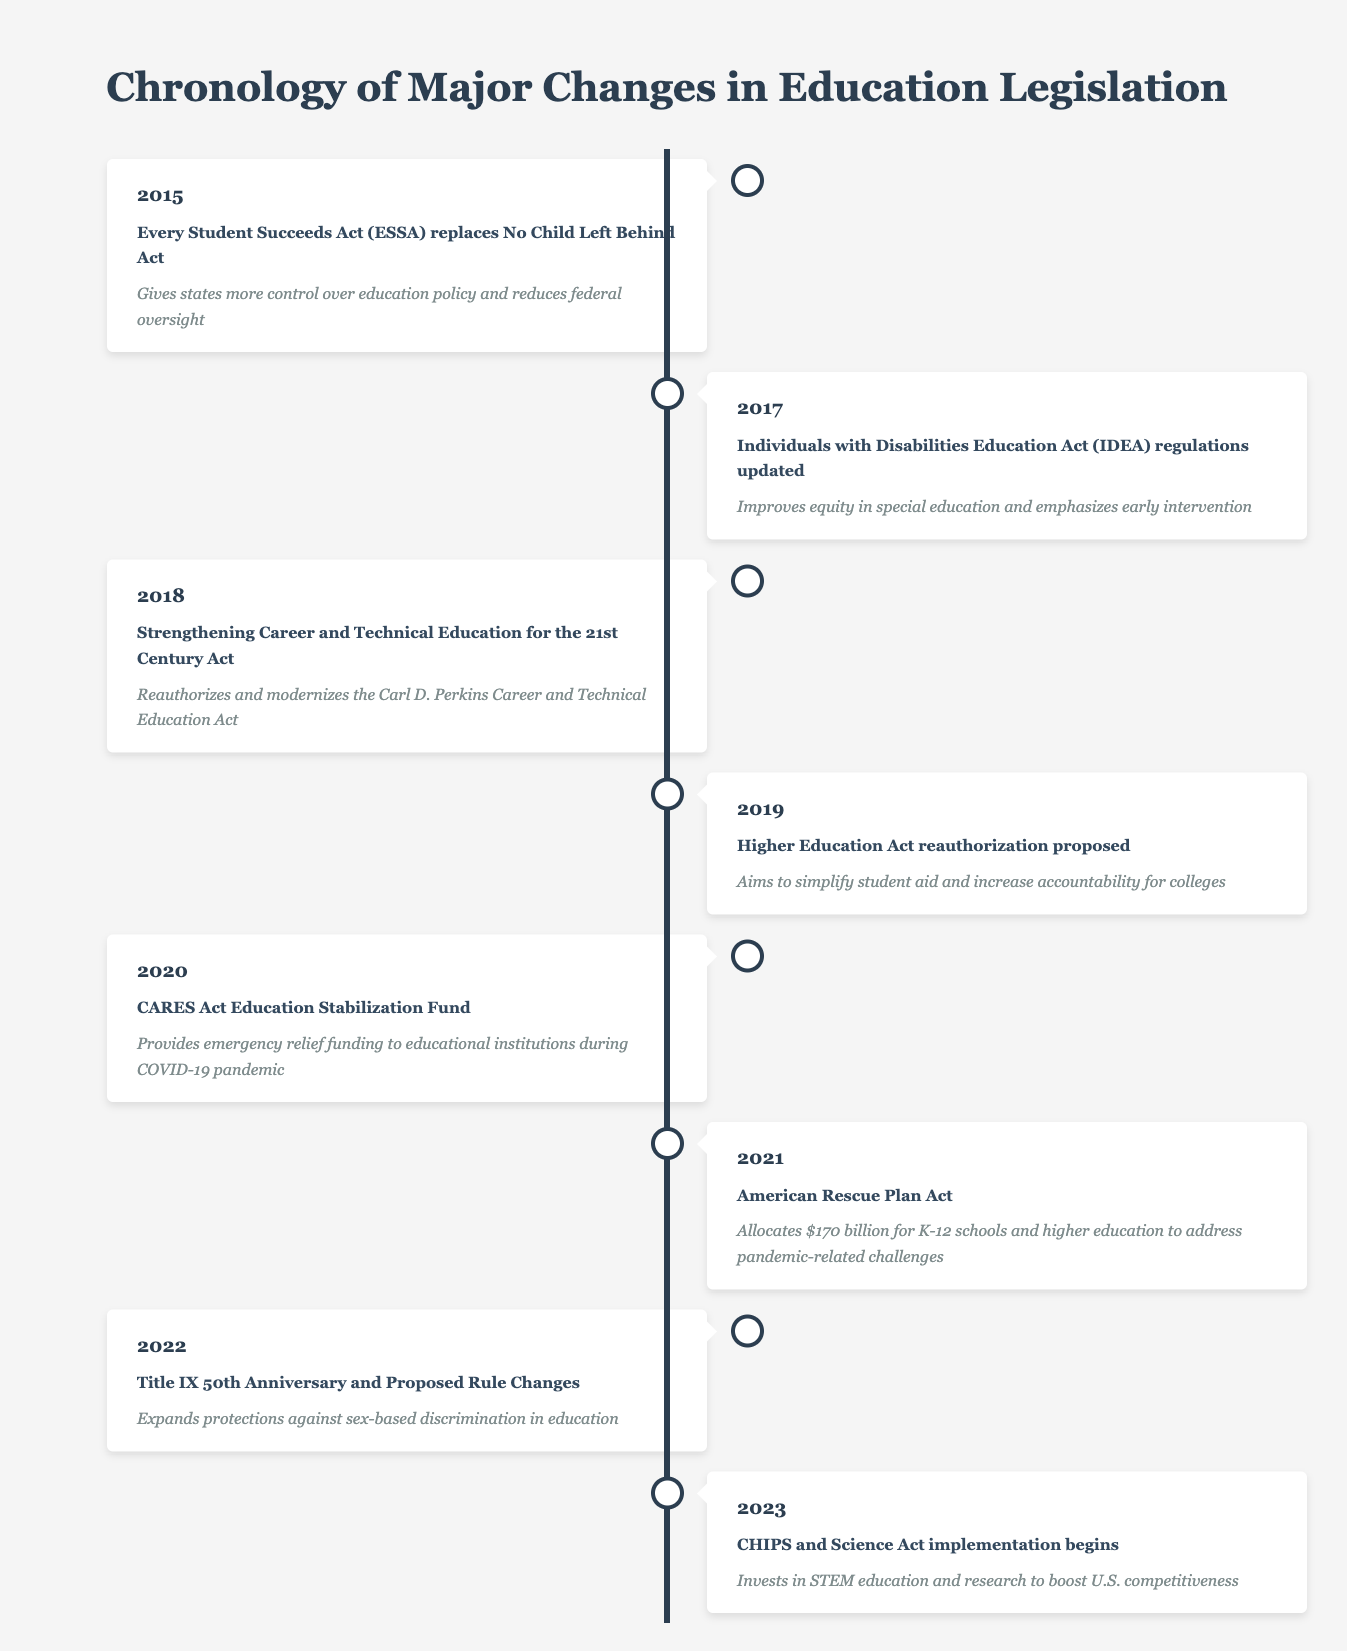What major act was replaced by the Every Student Succeeds Act in 2015? The table states that in 2015, the Every Student Succeeds Act (ESSA) replaced the No Child Left Behind Act. Therefore, the major act that was replaced is the No Child Left Behind Act.
Answer: No Child Left Behind Act How much funding was allocated for K-12 schools and higher education in the American Rescue Plan Act of 2021? According to the timeline, the American Rescue Plan Act in 2021 allocated $170 billion for K-12 schools and higher education to help address challenges presented by the pandemic.
Answer: $170 billion In which year was the Title IX 50th Anniversary and Proposed Rule Changes event noted? The table indicates that the Title IX 50th Anniversary and Proposed Rule Changes occurred in the year 2022.
Answer: 2022 True or False: The Strengthening Career and Technical Education for the 21st Century Act was enacted in 2019. The timeline specifies that this act was enacted in 2018, so the statement that it was enacted in 2019 is false.
Answer: False How many years passed between the update of the Individuals with Disabilities Education Act (IDEA) regulations and the American Rescue Plan Act? The IDEA regulations were updated in 2017 and the American Rescue Plan Act occurred in 2021. The difference between these years is 2021 - 2017 = 4 years.
Answer: 4 years What significant educational funding happened in 2020, and what was its impact? The CARES Act Education Stabilization Fund was established in 2020, providing emergency relief funding to educational institutions during the COVID-19 pandemic, thereby impacting their financial stability during a crisis.
Answer: CARES Act Education Stabilization Fund Identify the trend in education legislation from 2015 to 2023 based on the events listed. Over the years, legislation shifted towards providing more support for equity in education, improving funding in response to emergencies (e.g., COVID-19), and expanding protections against discrimination. The focus also included modernizing educational approaches (as seen with career and technical education).
Answer: Increased focus on equity and support in education What is the overarching common goal reflected in multiple legislative events from 2020 to 2023? The timeline suggests that the common goal is to address challenges arising from the COVID-19 pandemic and to promote educational competitiveness, particularly in STEM fields, through the respective acts and funding allocations within those years.
Answer: Addressing pandemic-related challenges and promoting competitiveness in education 